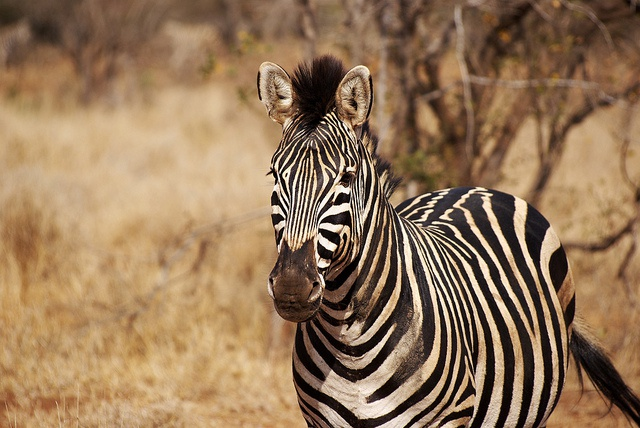Describe the objects in this image and their specific colors. I can see a zebra in black, tan, and beige tones in this image. 